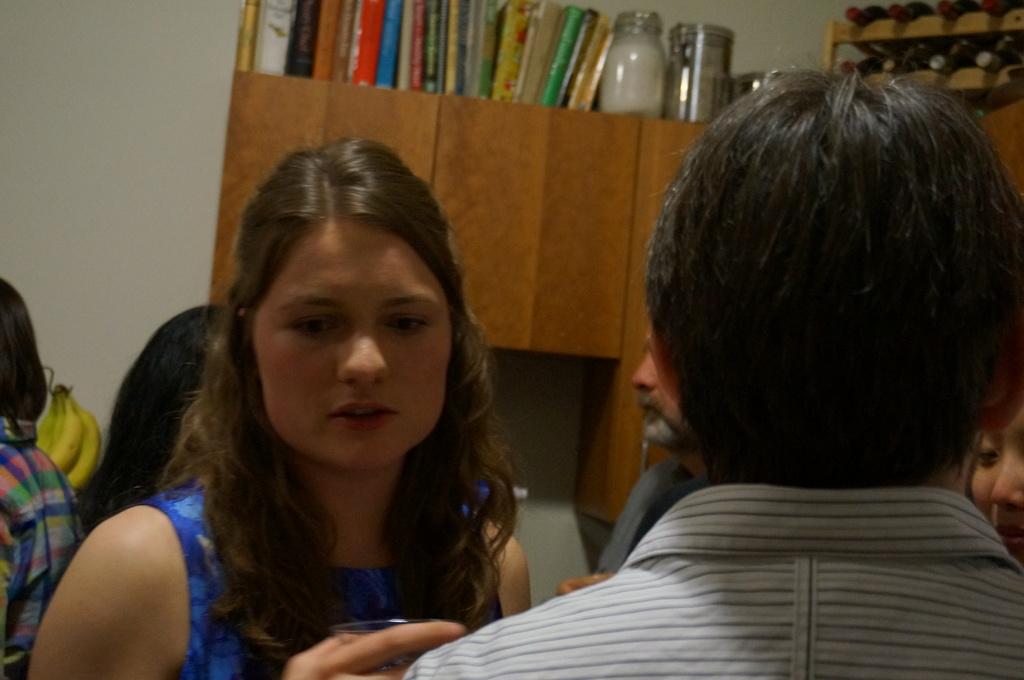What color is the dress that the woman is wearing?
Your answer should be very brief. Answering does not require reading text in the image. 